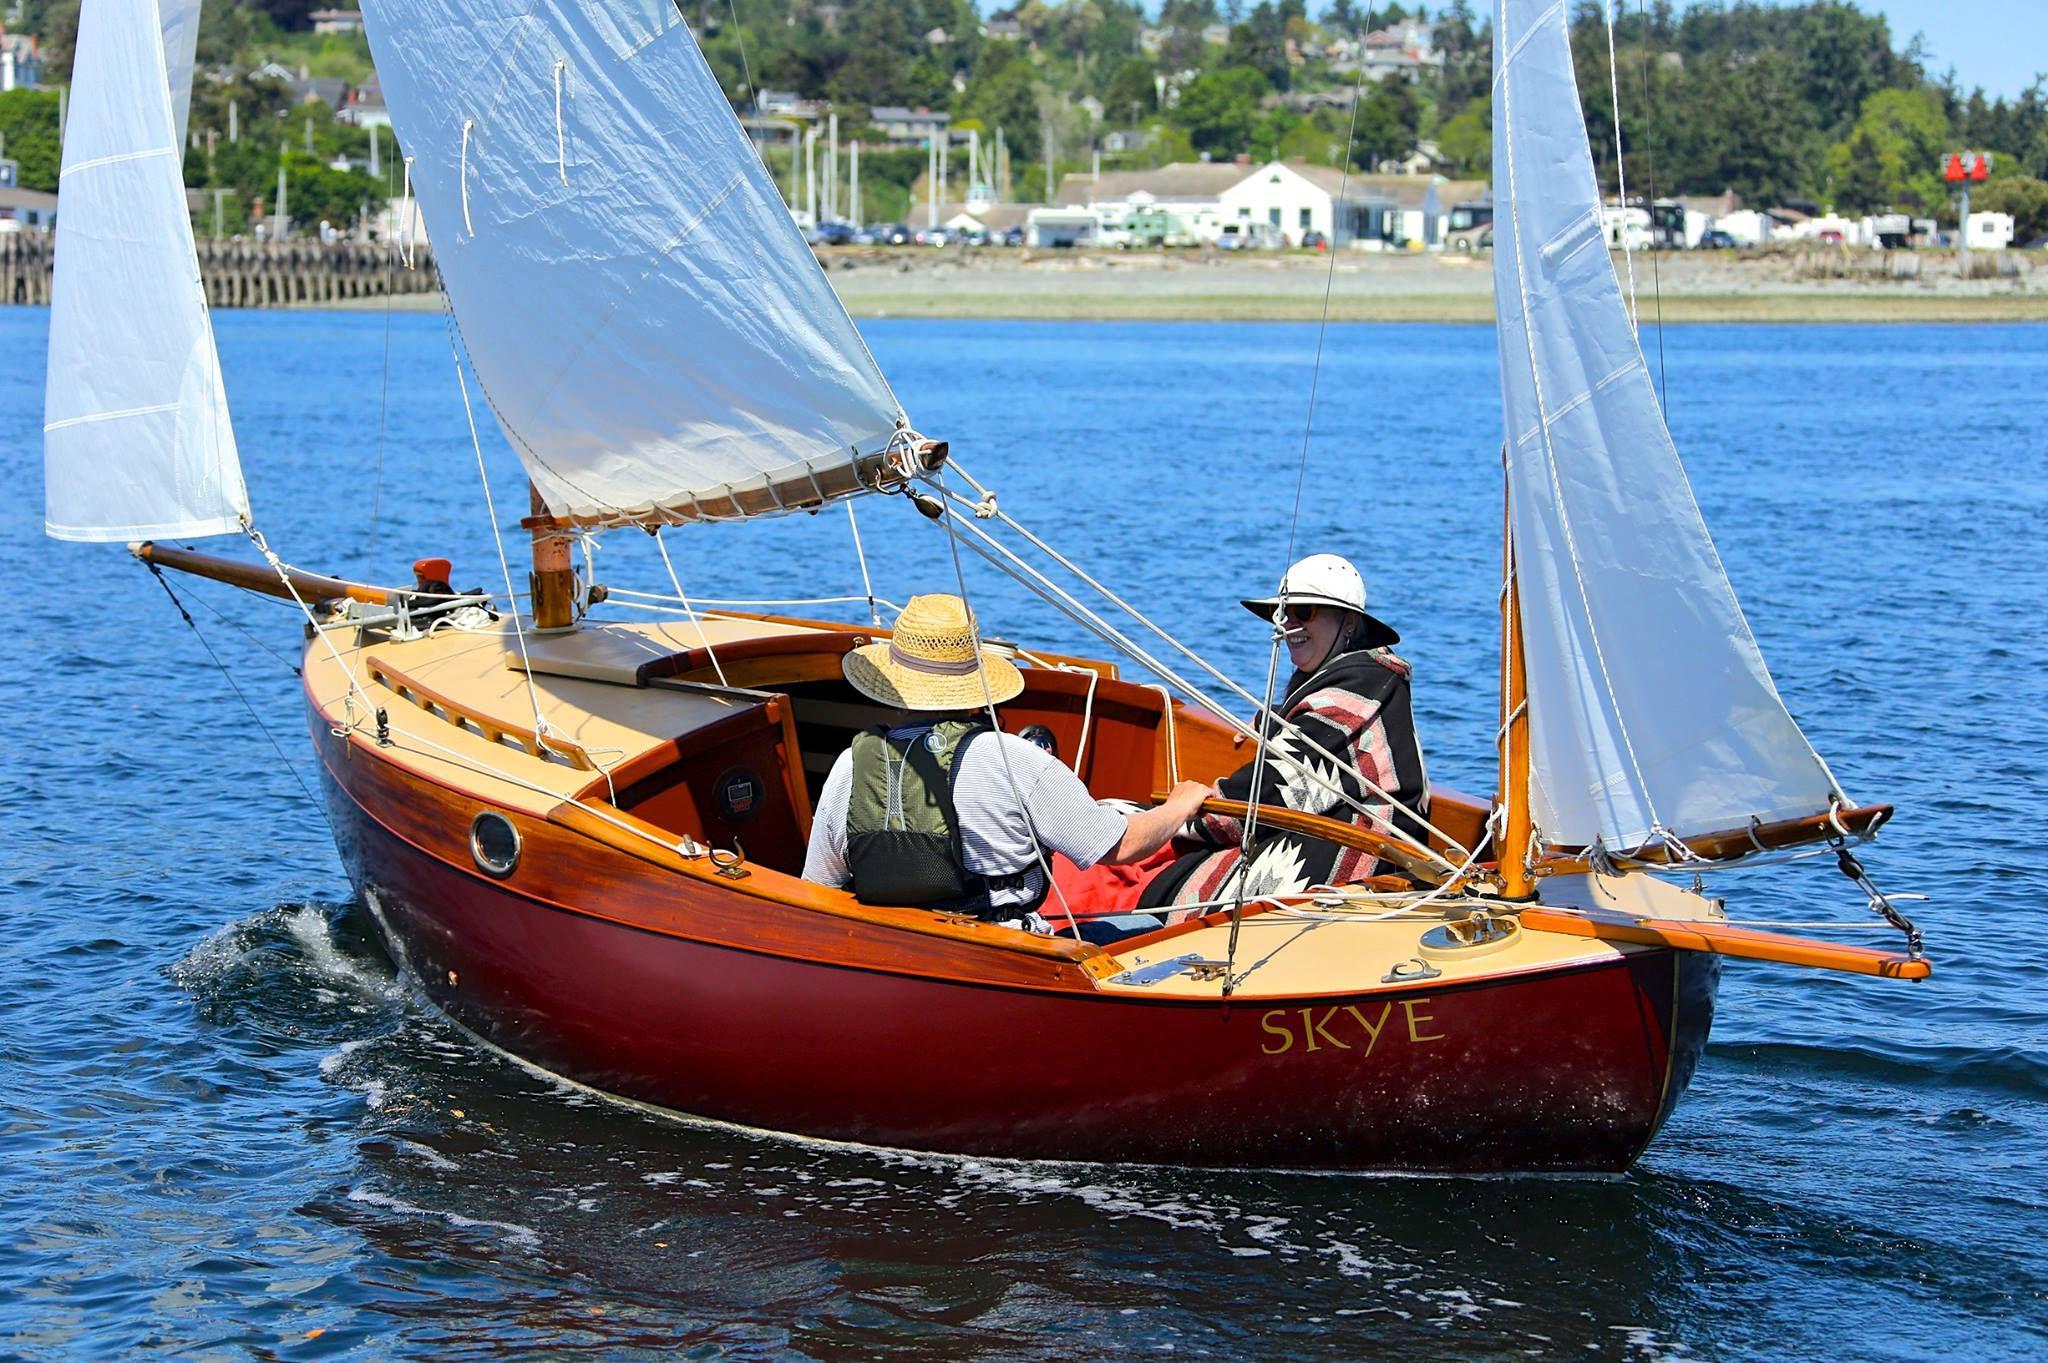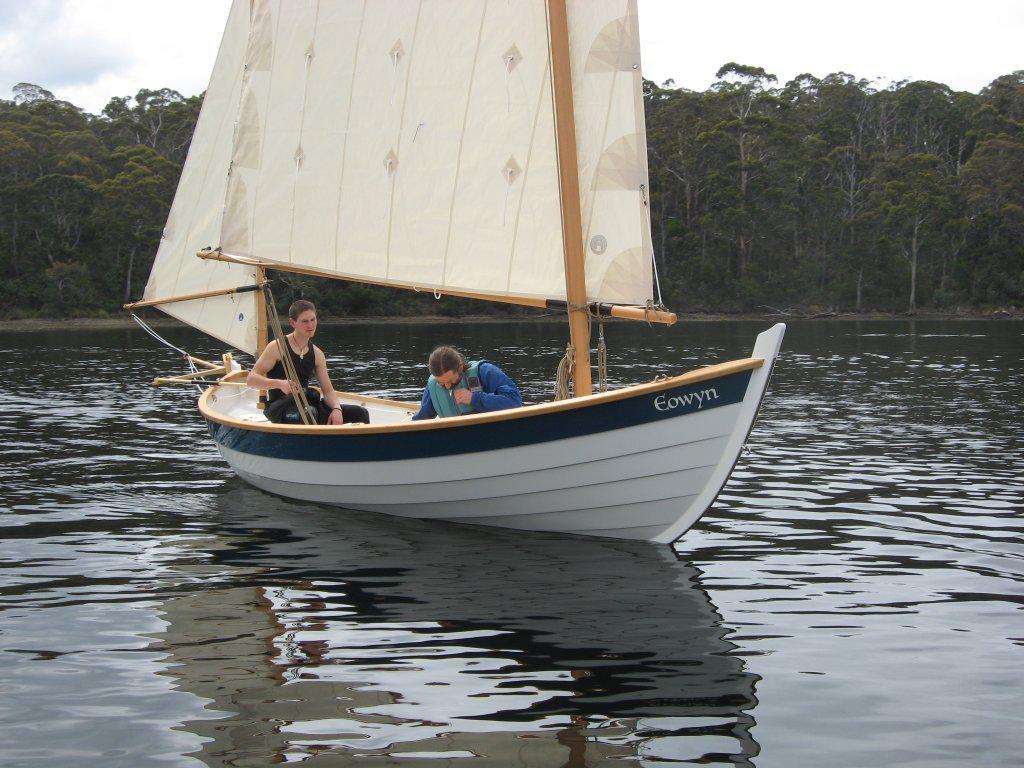The first image is the image on the left, the second image is the image on the right. Examine the images to the left and right. Is the description "All the sails are white." accurate? Answer yes or no. Yes. The first image is the image on the left, the second image is the image on the right. Considering the images on both sides, is "In the left image there is a person in a boat wearing a hate with two raised sails" valid? Answer yes or no. No. 